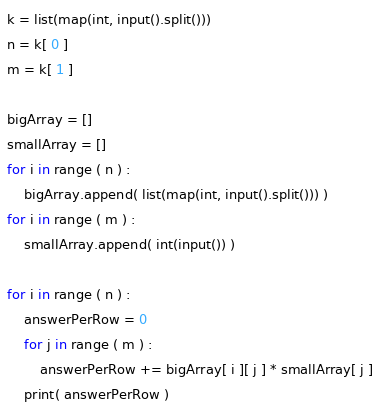<code> <loc_0><loc_0><loc_500><loc_500><_Python_>k = list(map(int, input().split()))
n = k[ 0 ]
m = k[ 1 ]

bigArray = []
smallArray = []
for i in range ( n ) :
    bigArray.append( list(map(int, input().split())) )
for i in range ( m ) :
    smallArray.append( int(input()) )

for i in range ( n ) :
    answerPerRow = 0
    for j in range ( m ) :
        answerPerRow += bigArray[ i ][ j ] * smallArray[ j ]
    print( answerPerRow )</code> 